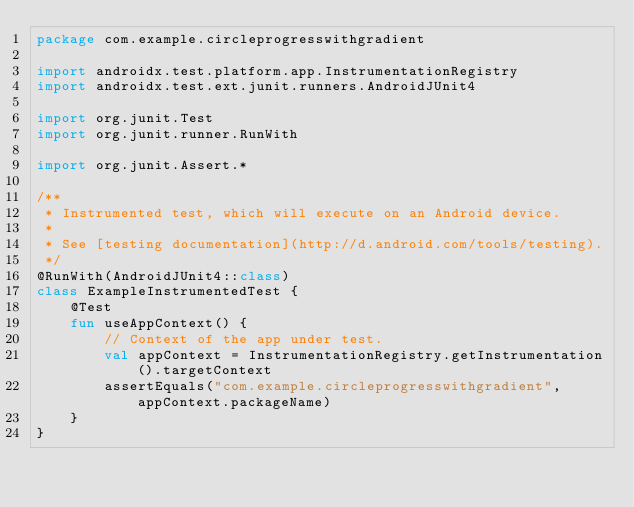Convert code to text. <code><loc_0><loc_0><loc_500><loc_500><_Kotlin_>package com.example.circleprogresswithgradient

import androidx.test.platform.app.InstrumentationRegistry
import androidx.test.ext.junit.runners.AndroidJUnit4

import org.junit.Test
import org.junit.runner.RunWith

import org.junit.Assert.*

/**
 * Instrumented test, which will execute on an Android device.
 *
 * See [testing documentation](http://d.android.com/tools/testing).
 */
@RunWith(AndroidJUnit4::class)
class ExampleInstrumentedTest {
    @Test
    fun useAppContext() {
        // Context of the app under test.
        val appContext = InstrumentationRegistry.getInstrumentation().targetContext
        assertEquals("com.example.circleprogresswithgradient", appContext.packageName)
    }
}</code> 